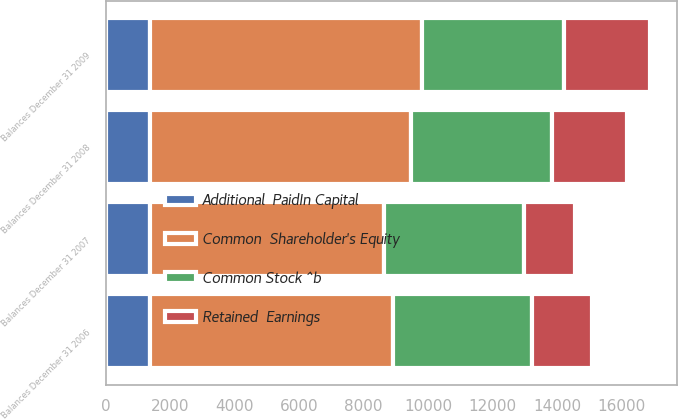Convert chart to OTSL. <chart><loc_0><loc_0><loc_500><loc_500><stacked_bar_chart><ecel><fcel>Balances December 31 2006<fcel>Balances December 31 2007<fcel>Balances December 31 2008<fcel>Balances December 31 2009<nl><fcel>Additional  PaidIn Capital<fcel>1373<fcel>1373<fcel>1373<fcel>1373<nl><fcel>Common Stock ^b<fcel>4318<fcel>4318<fcel>4393<fcel>4393<nl><fcel>Retained  Earnings<fcel>1848<fcel>1584<fcel>2323<fcel>2670<nl><fcel>Common  Shareholder's Equity<fcel>7539<fcel>7275<fcel>8089<fcel>8436<nl></chart> 